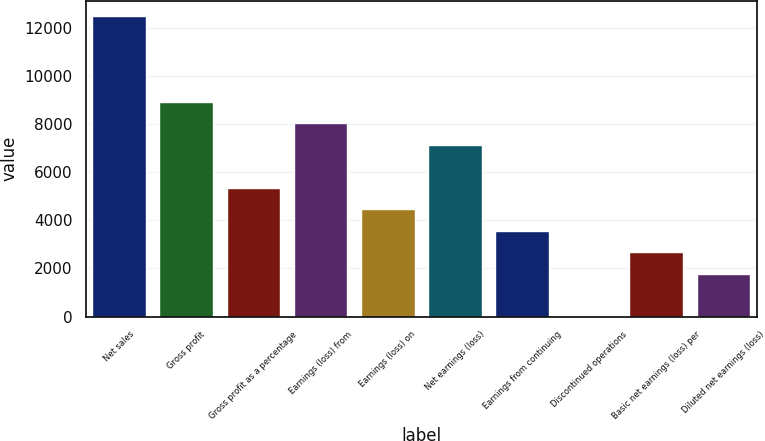Convert chart. <chart><loc_0><loc_0><loc_500><loc_500><bar_chart><fcel>Net sales<fcel>Gross profit<fcel>Gross profit as a percentage<fcel>Earnings (loss) from<fcel>Earnings (loss) on<fcel>Net earnings (loss)<fcel>Earnings from continuing<fcel>Discontinued operations<fcel>Basic net earnings (loss) per<fcel>Diluted net earnings (loss)<nl><fcel>12498.3<fcel>8927.42<fcel>5356.5<fcel>8034.69<fcel>4463.77<fcel>7141.96<fcel>3571.04<fcel>0.12<fcel>2678.31<fcel>1785.58<nl></chart> 